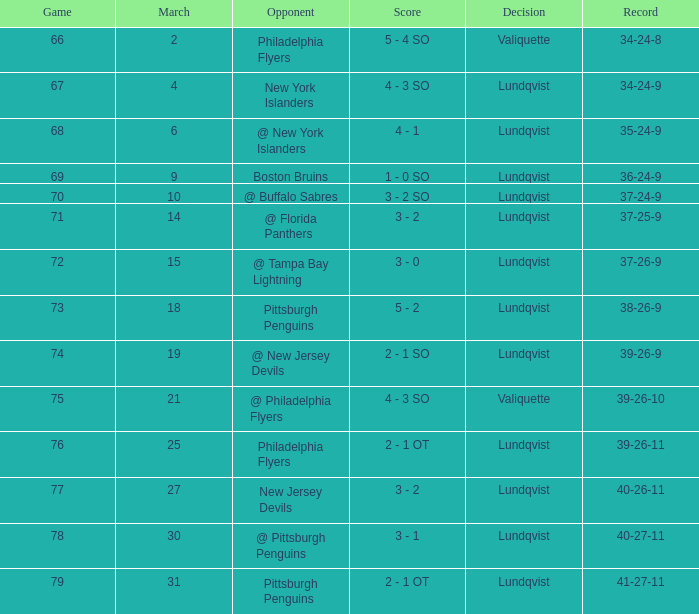Which rival's march was 31? Pittsburgh Penguins. 